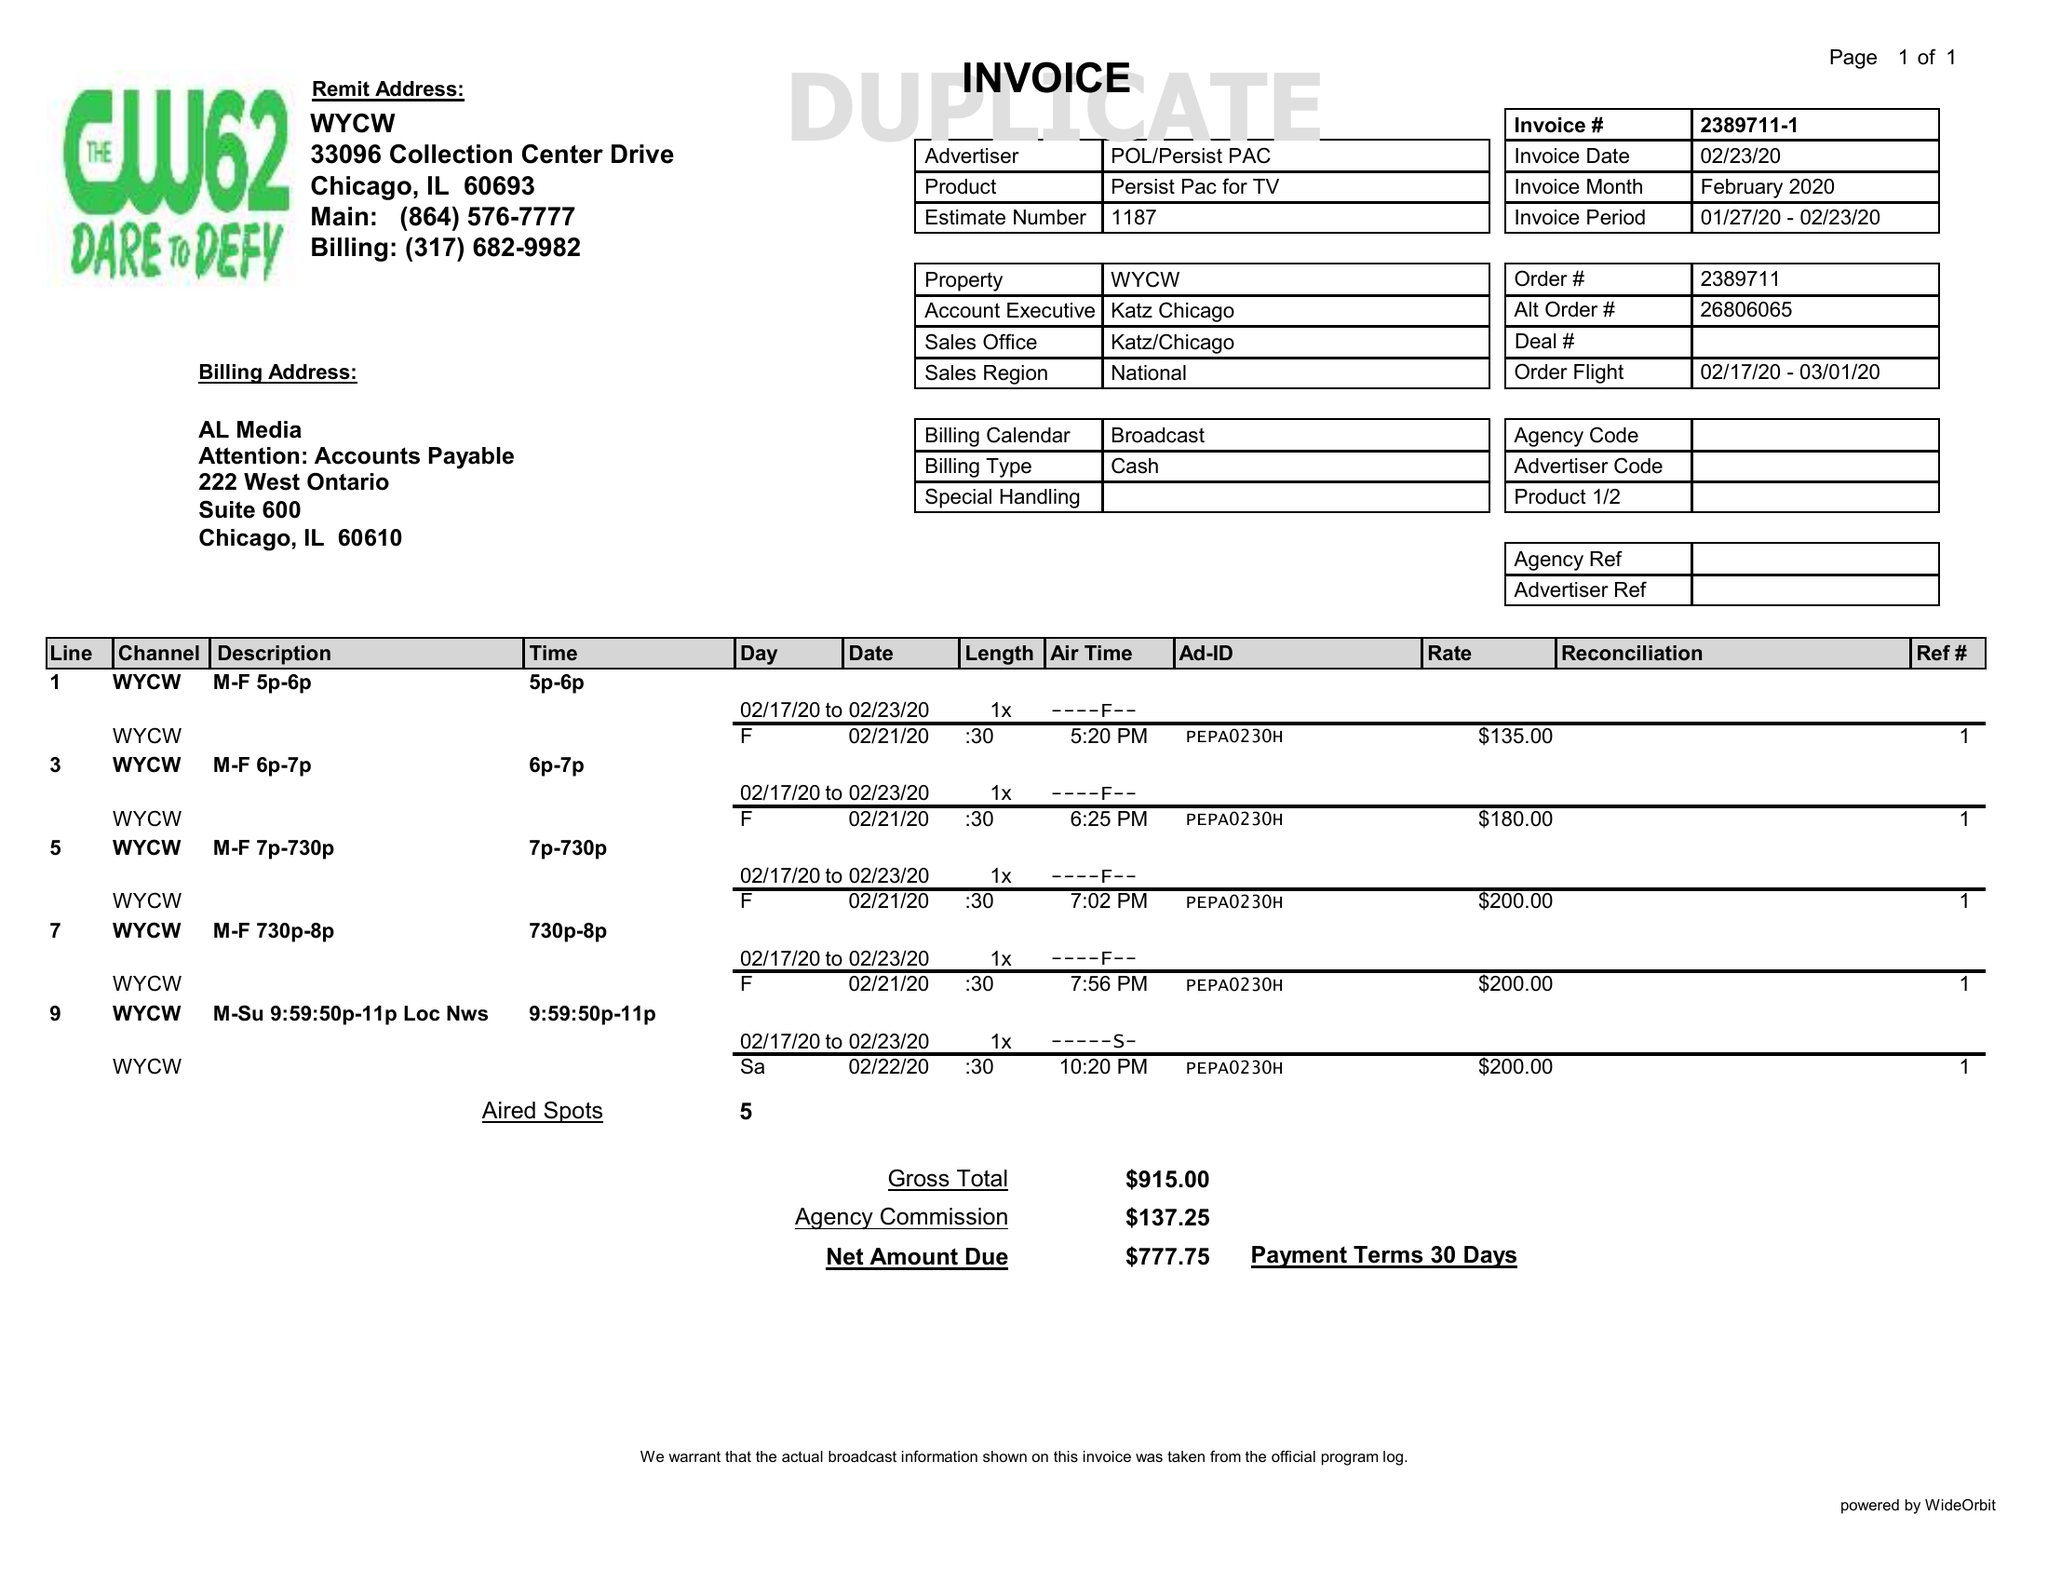What is the value for the gross_amount?
Answer the question using a single word or phrase. 915.00 